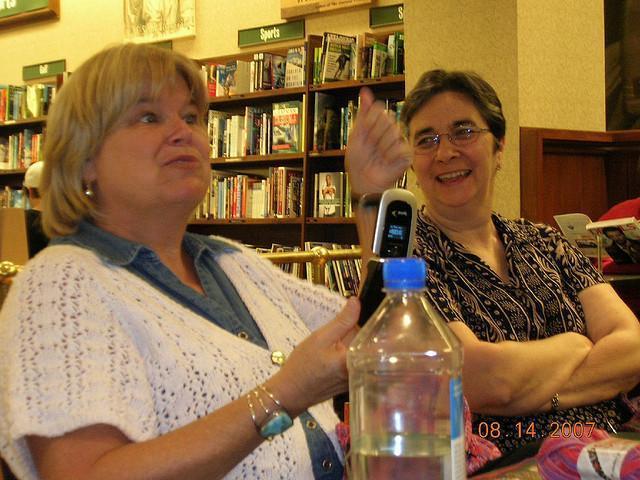How many cell phones are there?
Give a very brief answer. 1. How many people are there?
Give a very brief answer. 2. How many white birds are there?
Give a very brief answer. 0. 